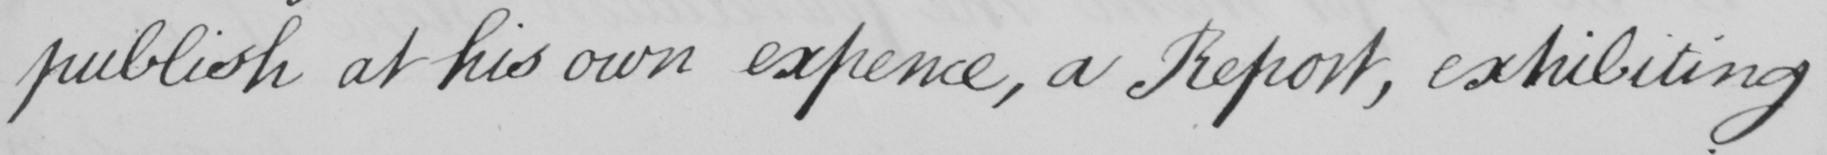What text is written in this handwritten line? publish at his own expence , a Report , exhibiting 